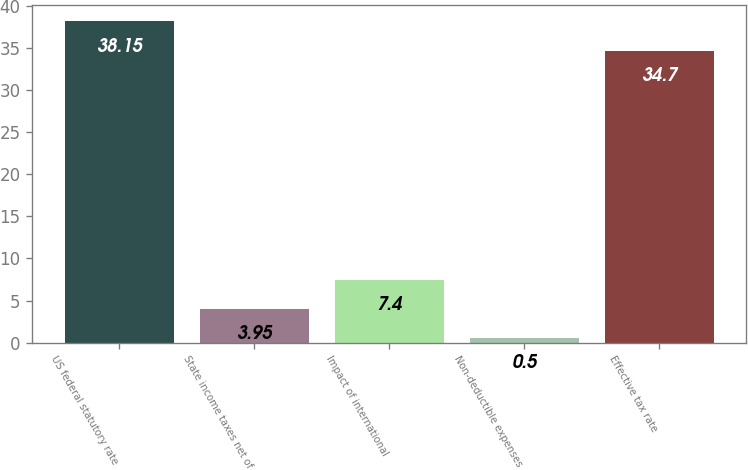Convert chart to OTSL. <chart><loc_0><loc_0><loc_500><loc_500><bar_chart><fcel>US federal statutory rate<fcel>State income taxes net of<fcel>Impact of international<fcel>Non-deductible expenses<fcel>Effective tax rate<nl><fcel>38.15<fcel>3.95<fcel>7.4<fcel>0.5<fcel>34.7<nl></chart> 